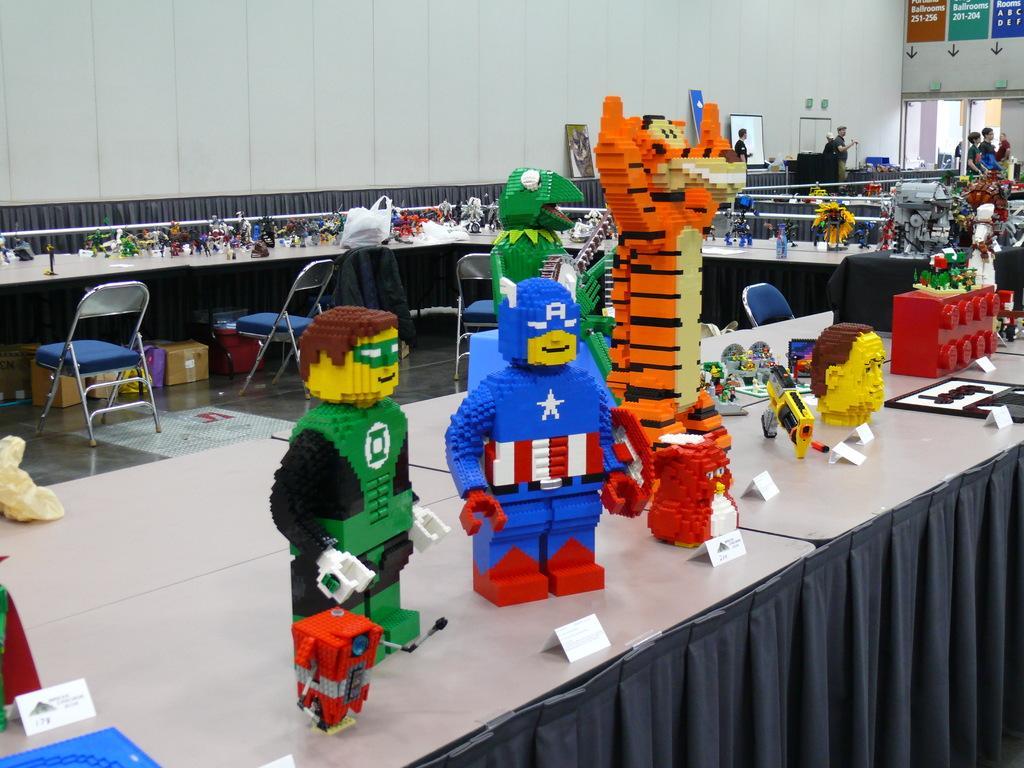Describe this image in one or two sentences. In this picture I can see number of tables, on which there are number of Lego toys and I can see few chairs. In the background I can see the wall and I see something is written on the top right corner of this picture. 